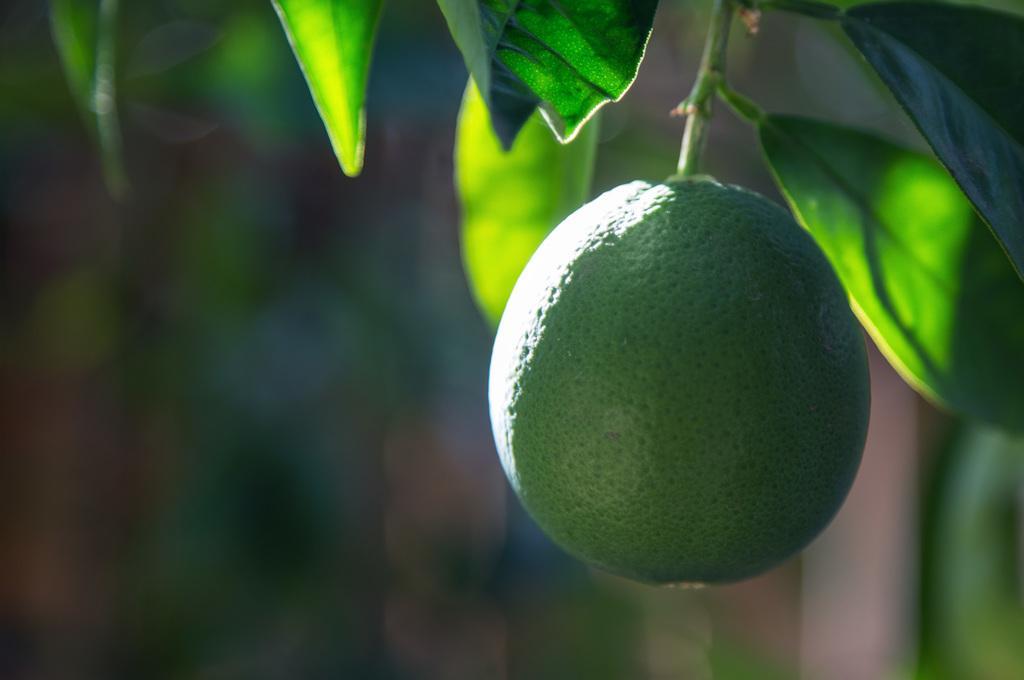Can you describe this image briefly? In this picture, we see the tree which has fruit and it looks like a lemon. It is green in color. In the background, it is green in color. This picture is blurred in the background. 